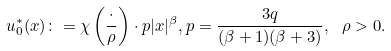Convert formula to latex. <formula><loc_0><loc_0><loc_500><loc_500>u ^ { * } _ { 0 } ( x ) \colon = \chi \left ( \frac { \cdot } { \rho } \right ) \cdot p | x | ^ { \beta } , p = \frac { 3 q } { ( \beta + 1 ) ( \beta + 3 ) } , \ \rho > 0 .</formula> 